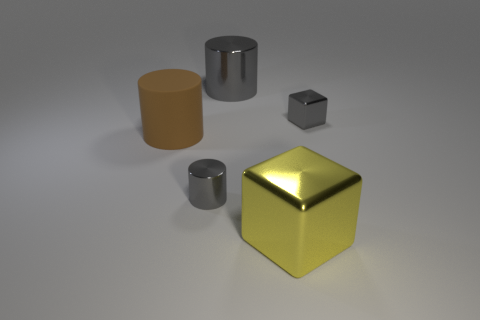What is the size of the yellow block that is the same material as the small gray cylinder?
Provide a short and direct response. Large. There is a large thing that is both on the left side of the large yellow block and in front of the gray metal cube; what is its material?
Offer a very short reply. Rubber. Does the large brown matte thing have the same shape as the yellow metallic object?
Provide a short and direct response. No. Is there anything else that has the same size as the brown cylinder?
Your answer should be very brief. Yes. There is a large brown matte thing; how many cylinders are behind it?
Provide a short and direct response. 1. There is a gray shiny cube that is behind the brown object; is its size the same as the big yellow block?
Give a very brief answer. No. What is the color of the small metal object that is the same shape as the big yellow metallic object?
Keep it short and to the point. Gray. Is there any other thing that has the same shape as the large brown matte thing?
Make the answer very short. Yes. The small gray thing left of the big yellow shiny thing has what shape?
Give a very brief answer. Cylinder. How many matte things are the same shape as the big gray metal thing?
Provide a succinct answer. 1. 